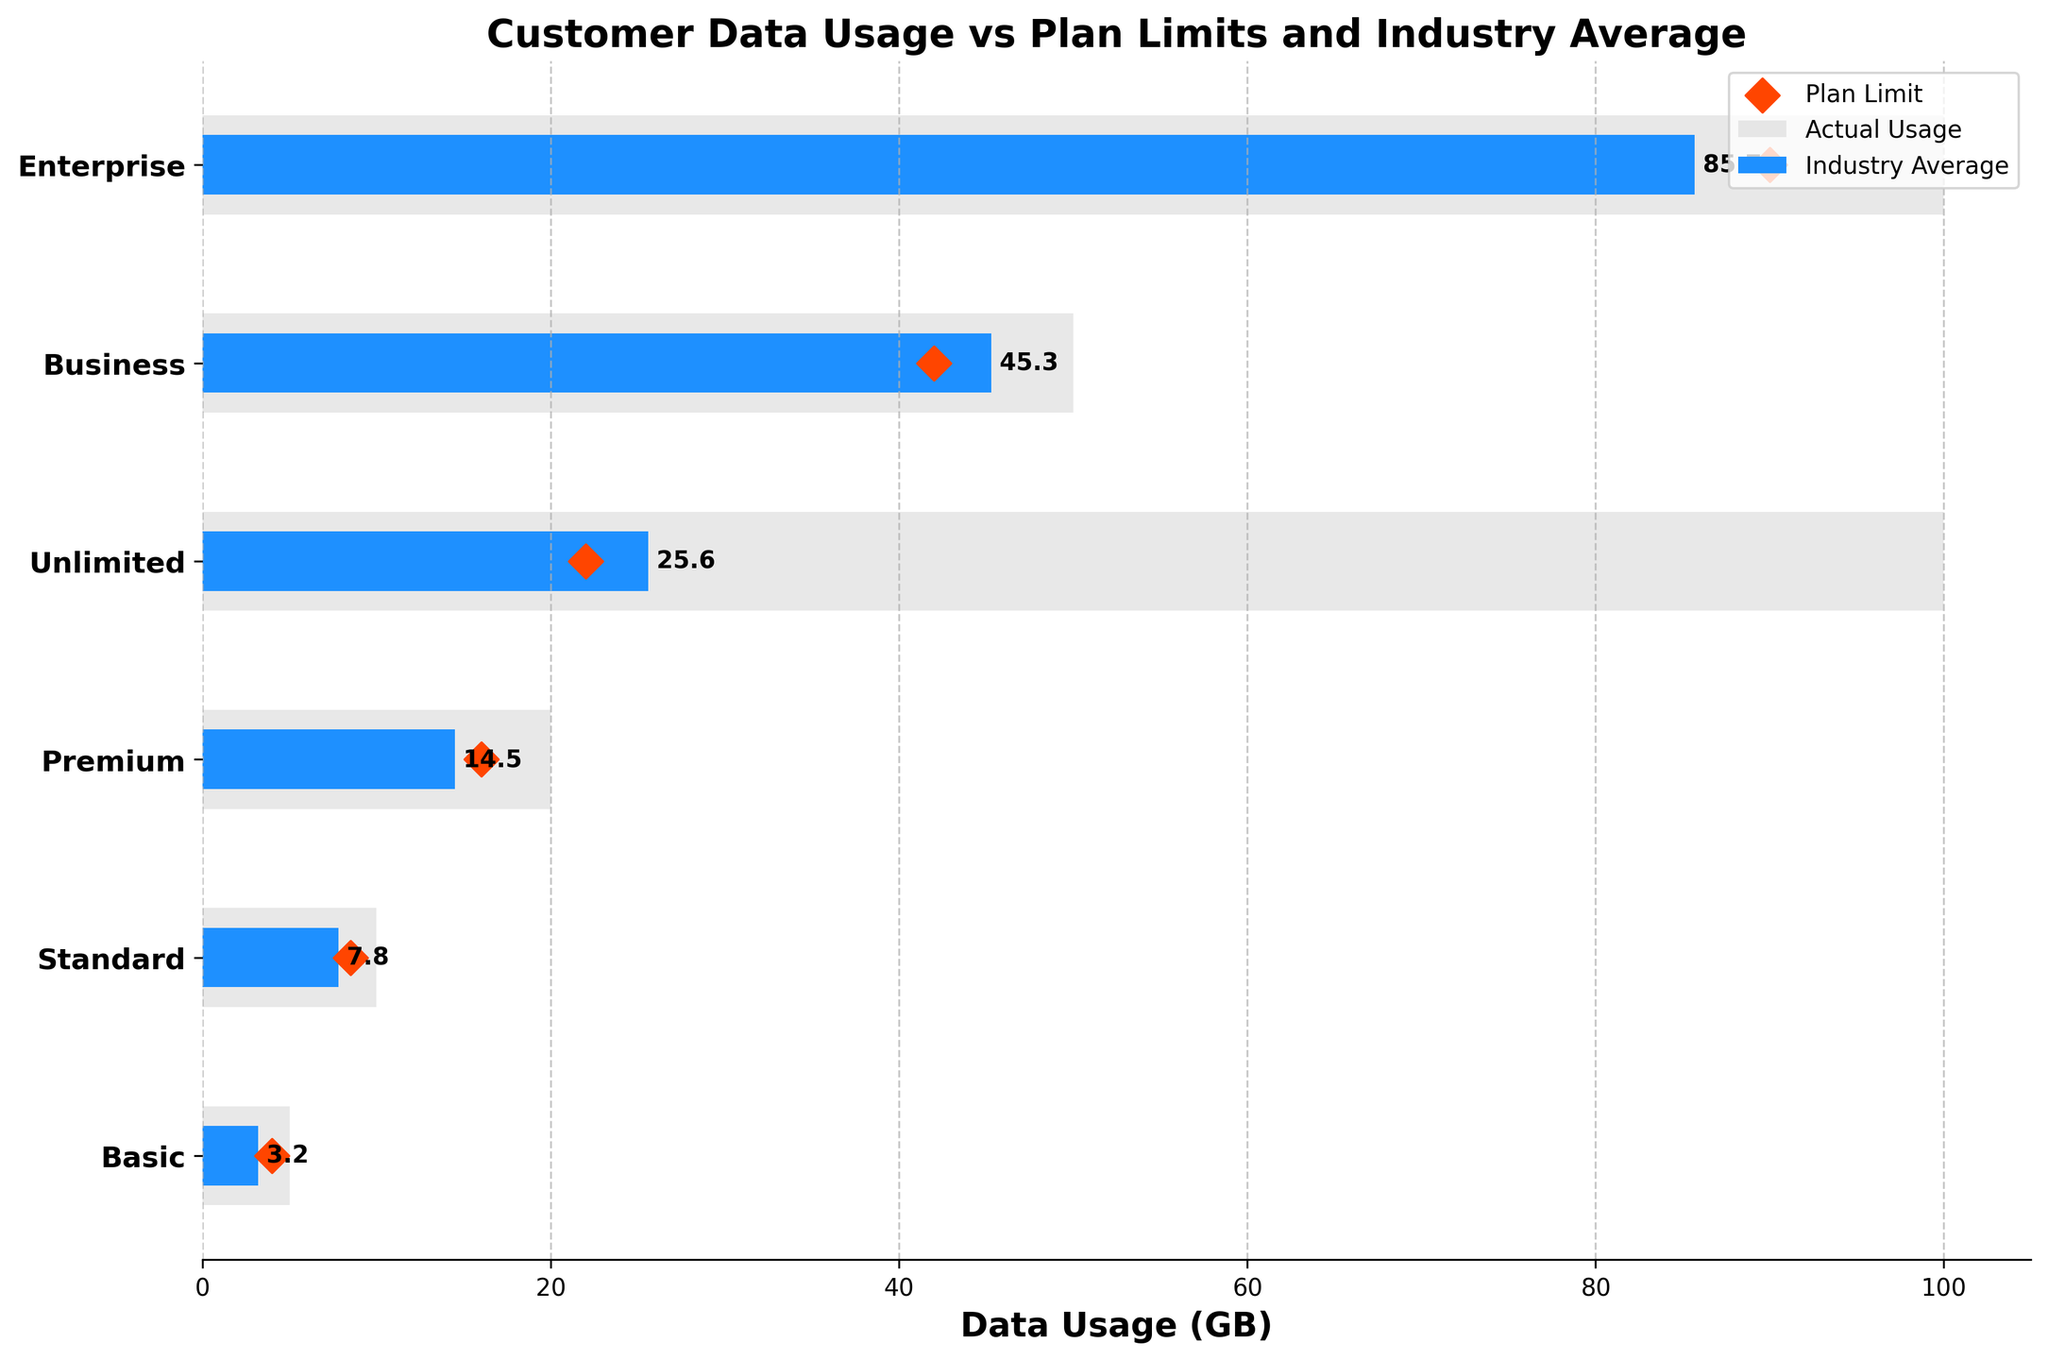What is the title of the chart? The title is displayed at the top of the chart.
Answer: Customer Data Usage vs Plan Limits and Industry Average What color represents the actual usage in the chart? The actual usage bars are colored in blue.
Answer: Blue Which service tier has the highest actual data usage? Look for the longest blue bar. The Enterprise tier has the longest blue bar, indicating the highest usage.
Answer: Enterprise How does the actual usage of the Standard service tier compare to its plan limit? Compare the blue bar (actual usage) to the grey bar (plan limit) for the Standard tier. The blue bar is shorter than the grey bar.
Answer: Less than the plan limit What is the industry average for the Premium service tier? Look for the orange diamond marker on the Premium service tier row. The diamond is at 16 GB.
Answer: 16 GB How much more data does the Enterprise tier use compared to the Business tier? Subtract the actual usage of the Business tier from the actual usage of the Enterprise tier: 85.7 GB - 45.3 GB.
Answer: 40.4 GB Is there any tier where actual usage exceeds the plan limit? Compare the actual usage bars (blue) with the plan limit bars (grey) for each tier.
Answer: No Which service tier has the smallest difference between its plan limit and actual usage? Calculate the differences for all tiers and compare them. The Basic tier has the smallest difference: 5 GB - 3.2 GB.
Answer: Basic What does the light grey color in the chart represent? The light grey color represents the plan limit bars for each service tier.
Answer: Plan Limit Compare the actual usage of the Business tier to the industry average for the same tier. The actual usage for the Business tier is 45.3 GB, and the industry average is 42 GB. Therefore, the Business tier's actual usage is slightly higher than the industry average.
Answer: Higher than industry average 